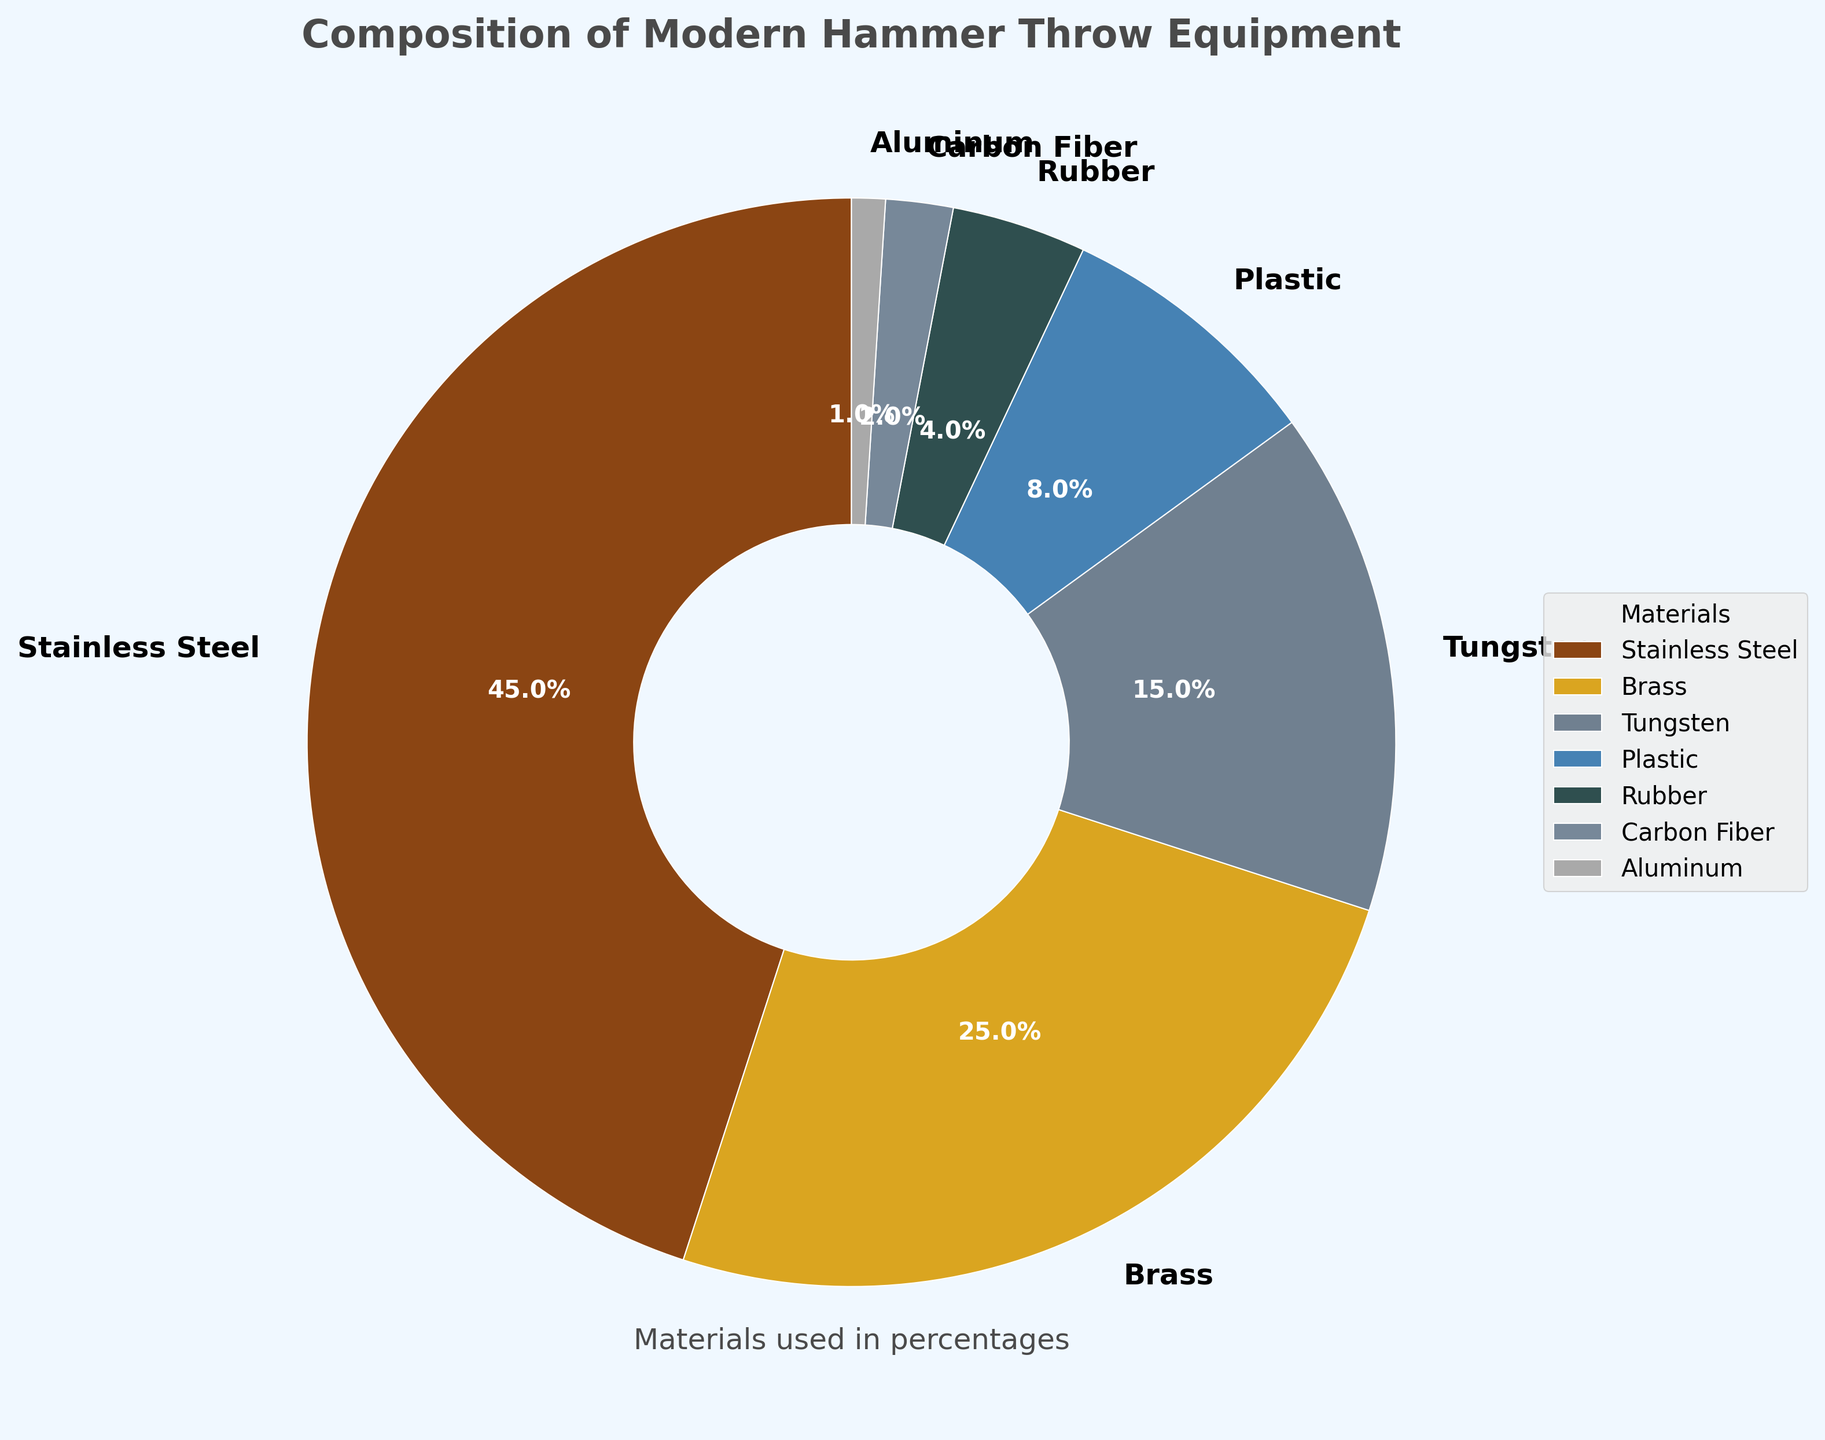Which material is used the most in modern hammer throw equipment? By visually inspecting the largest section of the pie chart, we can see that Stainless Steel has the largest portion at 45%.
Answer: Stainless Steel What is the total percentage of non-metal materials used in the hammer? Identify and sum the non-metal materials' percentages: Plastic (8%), Rubber (4%), and Carbon Fiber (2%). So, 8 + 4 + 2 = 14%.
Answer: 14% Which material has a larger percentage, Tungsten or Brass? By comparing the pie chart sections for Tungsten (15%) and Brass (25%), it's clear that Brass has a larger percentage.
Answer: Brass What is the combined percentage of materials that have at least 10% composition each? Identify the relevant materials: Stainless Steel (45%) and Brass (25%), and Tungsten (15%). Sum them up: 45 + 25 + 15 = 85%.
Answer: 85% How much more is the percentage of Stainless Steel compared to Aluminum? Subtract the percentage of Aluminum (1%) from the percentage of Stainless Steel (45%): 45 - 1 = 44%.
Answer: 44% Which materials have percentages less than Plastic? Identify that Plastic has 8%. Look at materials with percentages less than 8%: Rubber (4%), Carbon Fiber (2%), and Aluminum (1%).
Answer: Rubber, Carbon Fiber, Aluminum What is the percentage difference between the most used material and the least used material? Identify the most used (Stainless Steel, 45%) and the least used (Aluminum, 1%) materials. Subtract to find the difference: 45 - 1 = 44%.
Answer: 44% If we combine Carbon Fiber and Aluminum, what percentage do they contribute together? Sum the percentages of Carbon Fiber (2%) and Aluminum (1%): 2 + 1 = 3%.
Answer: 3% What is the ratio of the percentage of Brass to the percentage of Tungsten? Compare Brass (25%) to Tungsten (15%) by division: 25 / 15 = 1.67.
Answer: 1.67 Which section of the pie chart uses a grey-like color? Describe the color code for Tungsten, which visually appears as a grey-like color on the pie chart.
Answer: Tungsten 